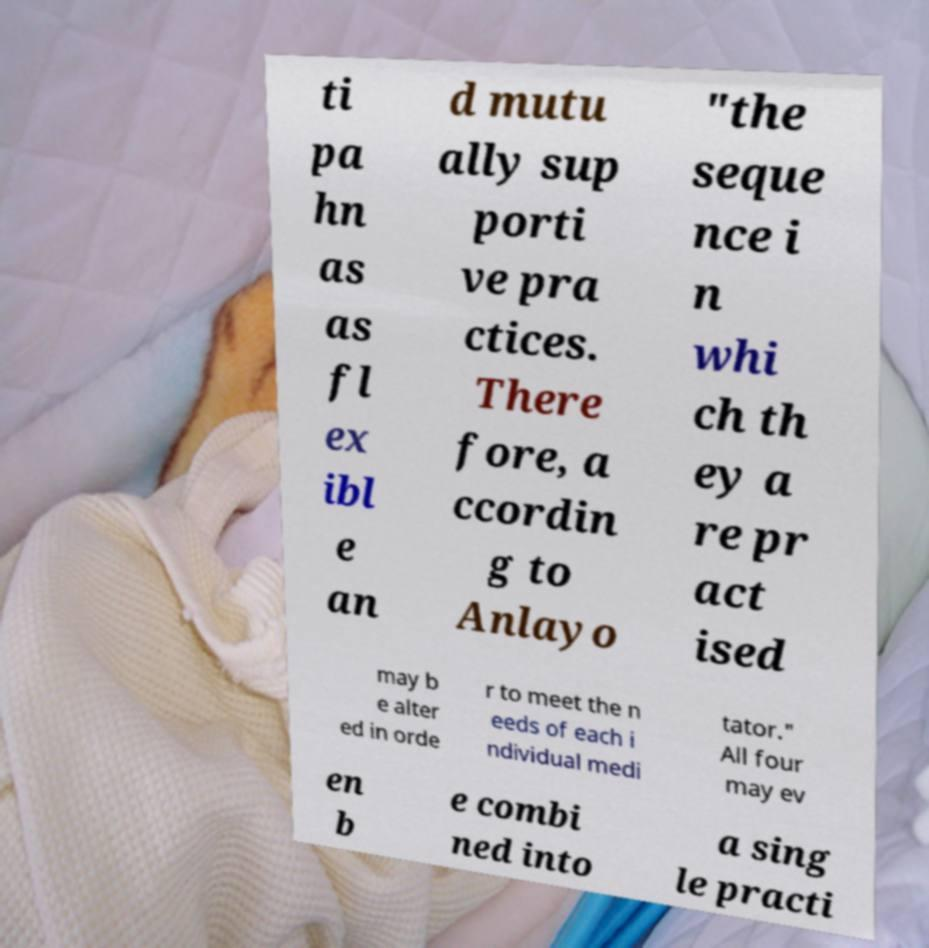Please read and relay the text visible in this image. What does it say? ti pa hn as as fl ex ibl e an d mutu ally sup porti ve pra ctices. There fore, a ccordin g to Anlayo "the seque nce i n whi ch th ey a re pr act ised may b e alter ed in orde r to meet the n eeds of each i ndividual medi tator." All four may ev en b e combi ned into a sing le practi 